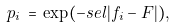<formula> <loc_0><loc_0><loc_500><loc_500>p _ { i } \, = \, \exp ( - s e l | f _ { i } - F | ) ,</formula> 